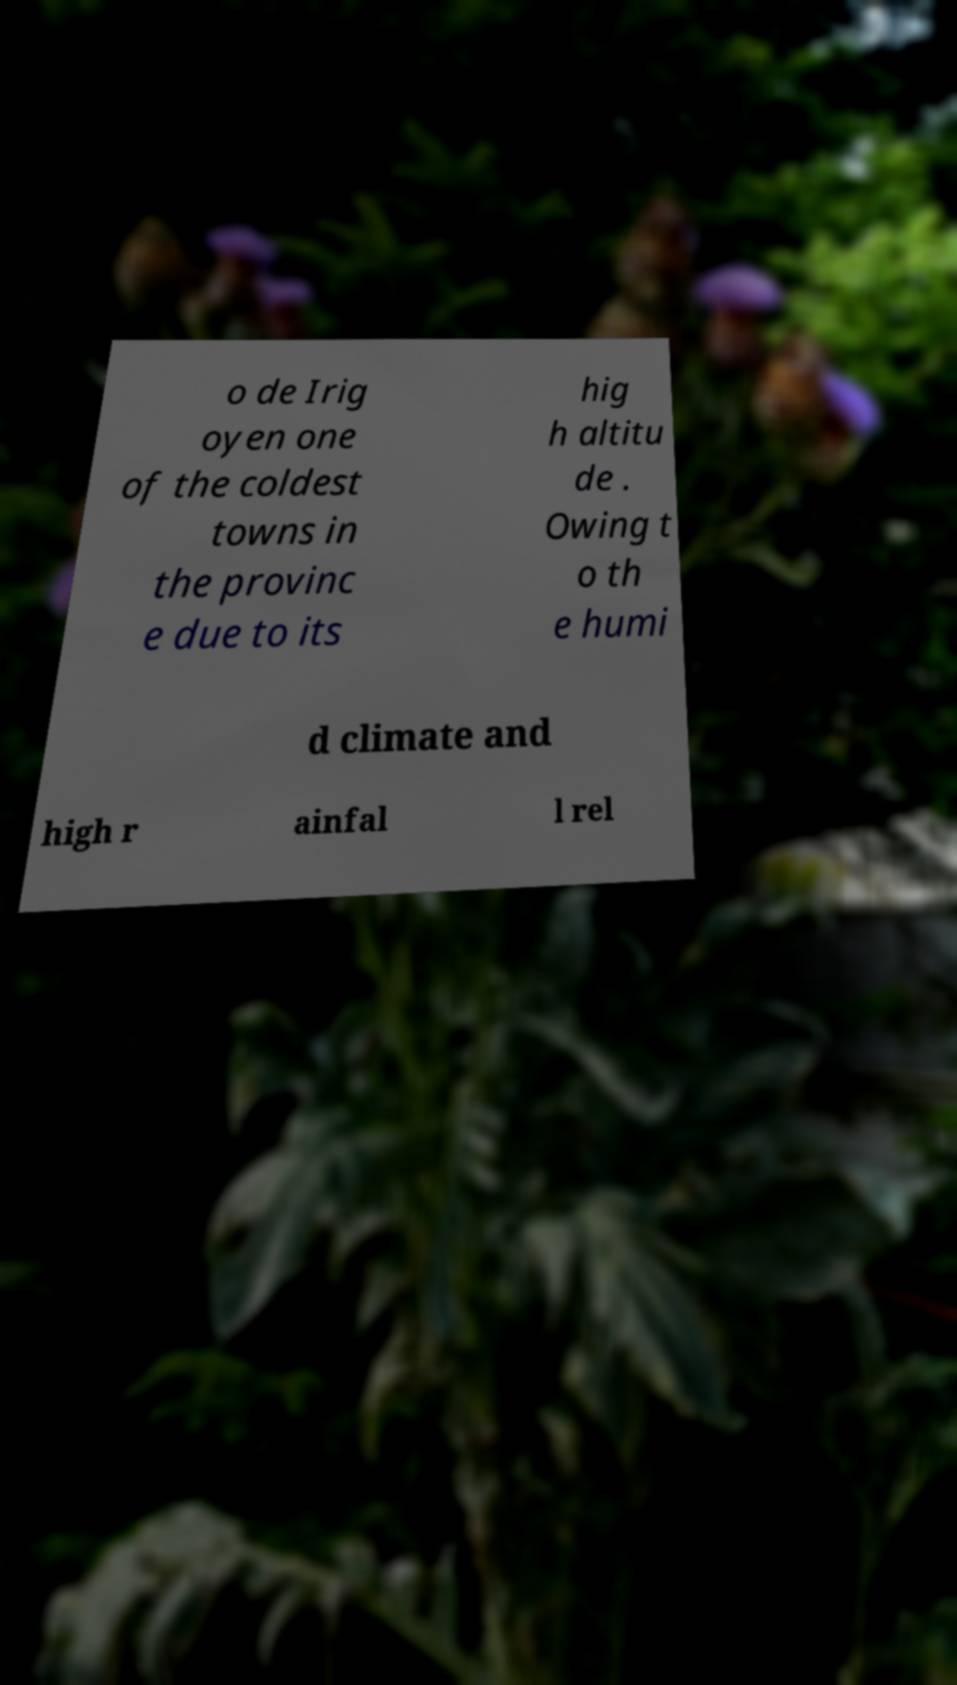For documentation purposes, I need the text within this image transcribed. Could you provide that? o de Irig oyen one of the coldest towns in the provinc e due to its hig h altitu de . Owing t o th e humi d climate and high r ainfal l rel 